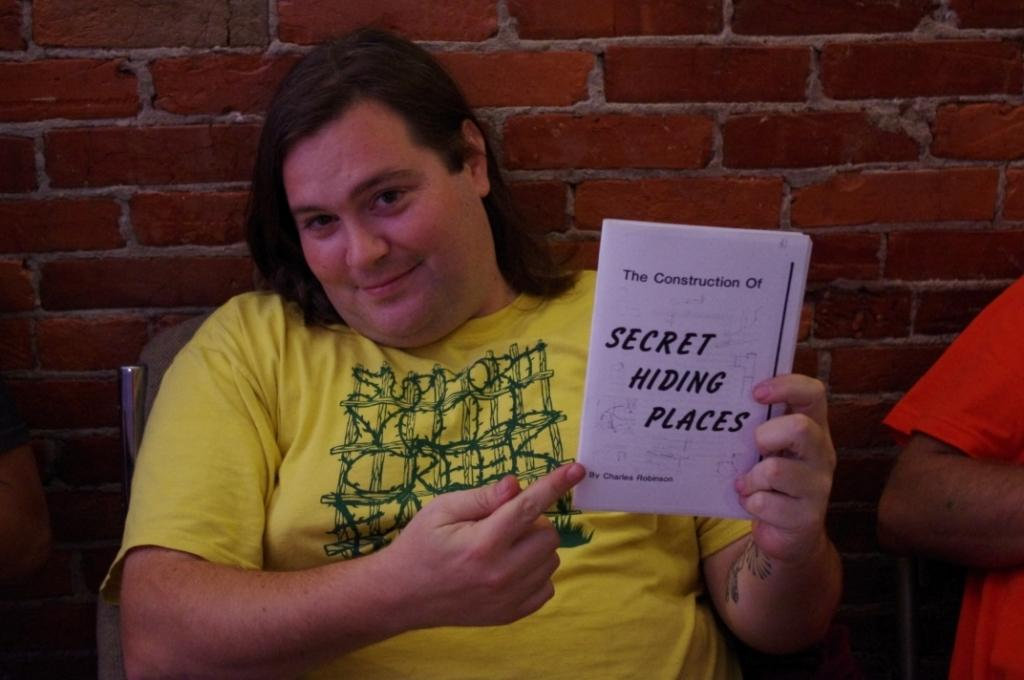<image>
Give a short and clear explanation of the subsequent image. A person in a yellow shirt is holding a white booklet that reads Secret Hiding Places 